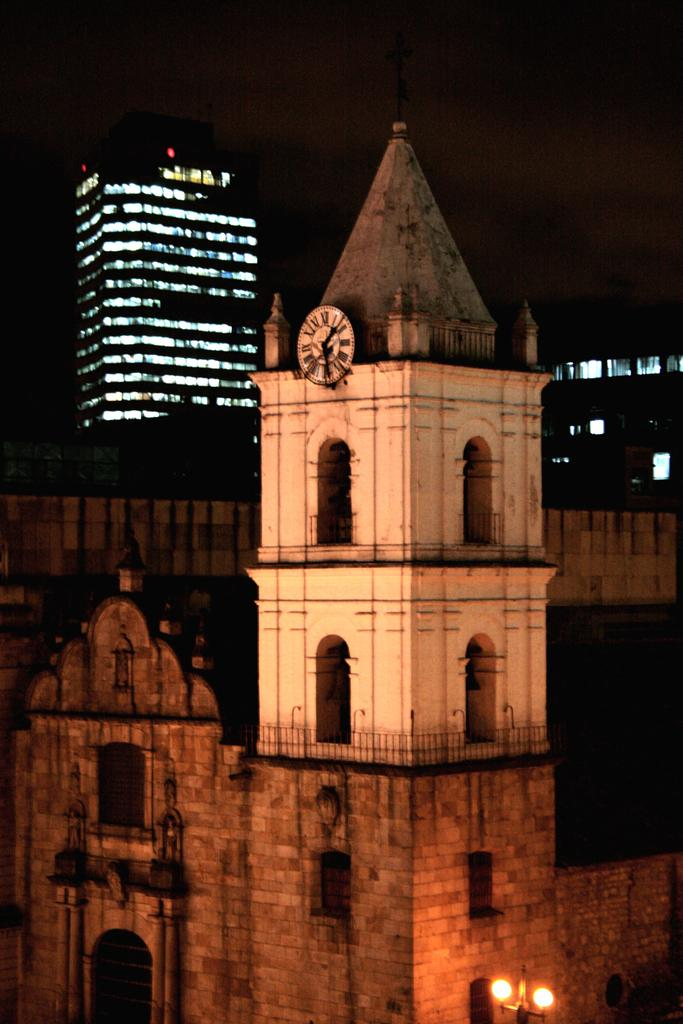What type of structure is in the image? There is a building in the image. What features can be seen on the building? The building has windows and doors. What additional objects are present in the image? There are lights on a pole and a clock on the wall in the image. How would you describe the lighting conditions in the image? The background of the image is dark, but there are lights visible in the background. What can be seen in the sky in the image? The sky is visible in the background of the image. What else is visible in the background? There are buildings visible in the background. What type of good-bye message is written on the building in the image? There is no good-bye message written on the building in the image. How does the building express regret in the image? The building does not express regret in the image; it is an inanimate object. What type of winter clothing is visible on the people in the image? There are no people visible in the image, so it is impossible to determine if any winter clothing is present. 